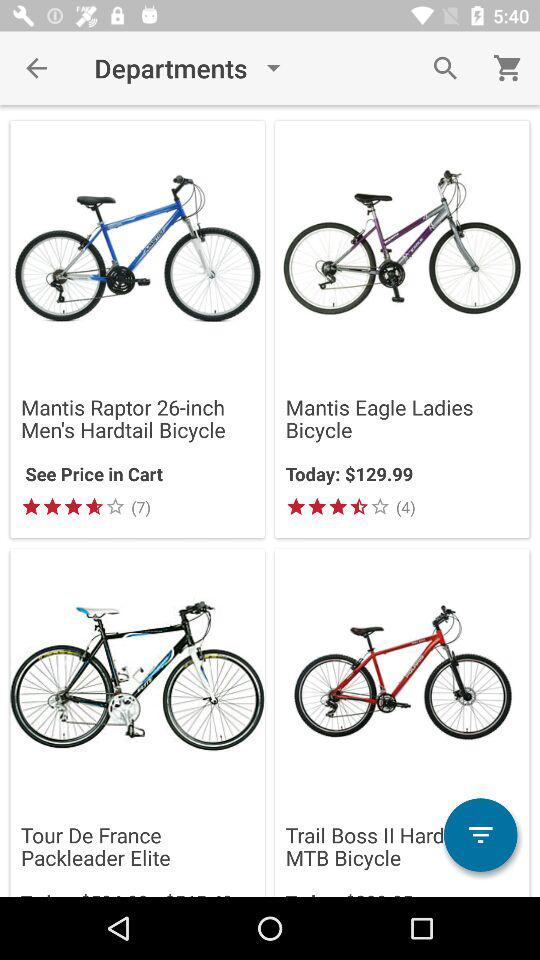What is the current price of the Mantis Eagle ladies' bicycle? The current price of the Mantis Eagle ladies' bicycle is $129.99. 